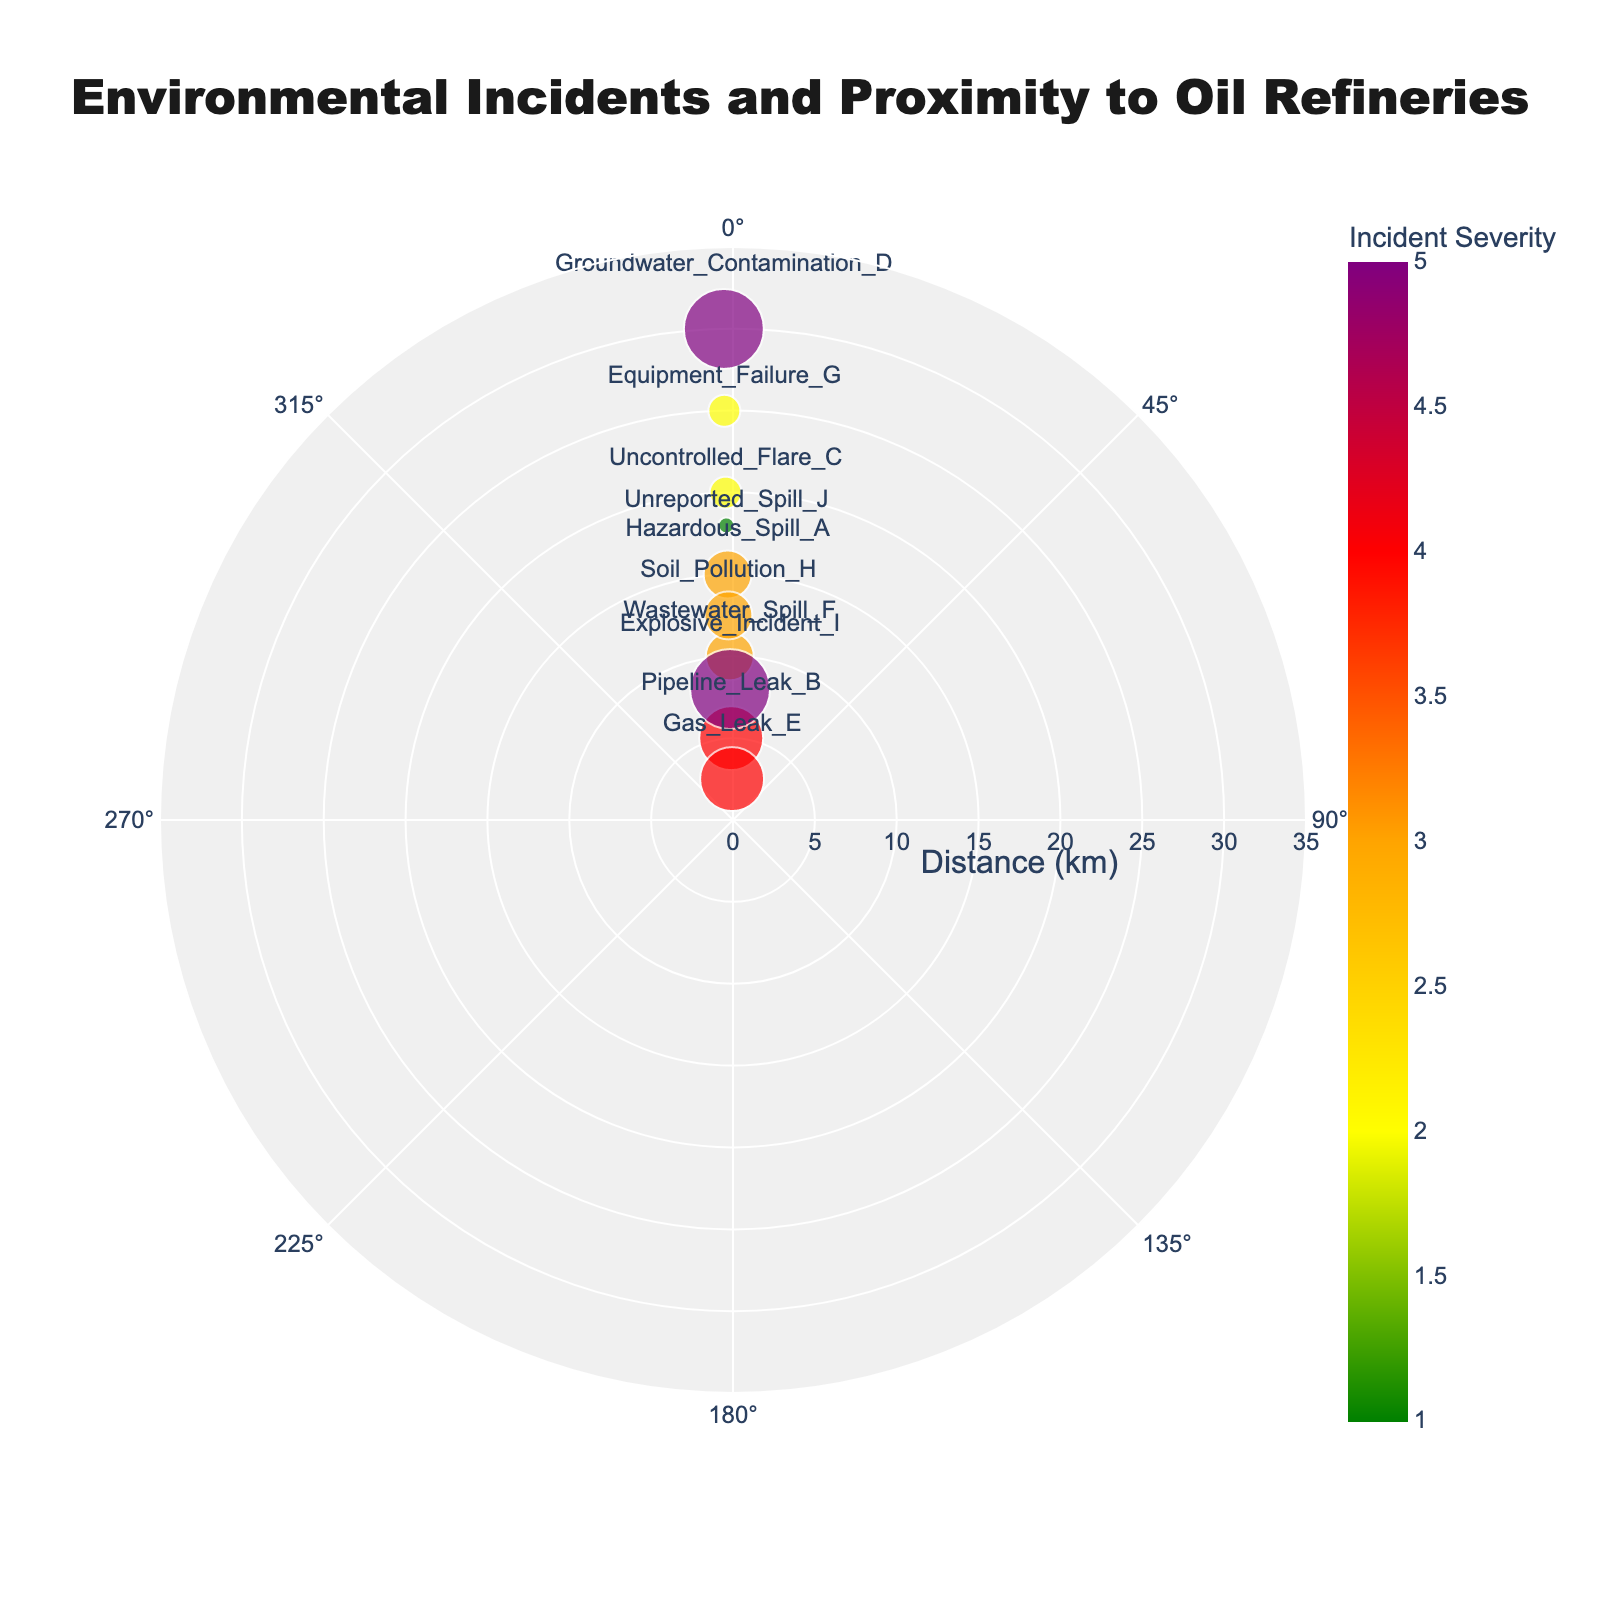What is the title of the figure? The title is usually the largest text at the top of the figure. It summarizes the main information presented.
Answer: Environmental Incidents and Proximity to Oil Refineries Which incident is the closest to the refinery? Identify the smallest 'Distance_to_Refinery_km' value in the plot. The smallest marker distance from the center corresponds to the closest incident.
Answer: Gas_Leak_E What color represents the highest incident severity on the color bar? Observe the color bar on the right side of the plot. The highest value should be at the top of the bar.
Answer: Purple How many incidents have a severity level of 5? Count the number of markers colored with the purple hue, corresponding to the highest severity level on the color bar.
Answer: 3 Which incident is located farthest from the refinery? Look for the marker farthest from the center of the plot, which represents the highest distance.
Answer: Groundwater_Contamination_D What is the average distance of incidents with a severity level of 4? Identify the distances for incidents with severity level 4, then calculate the average. The distances are 5.0 and 2.5 km. Average = (5.0 + 2.5) / 2 = 3.75 km.
Answer: 3.75 km Is there a relationship between distance from the refinery and incident severity? Explain. Observe if incidents with higher severity are closer or further from the center (0 km). Typically, high-severity incidents are closer to the refinery, visible as larger markers near the center.
Answer: Higher severity incidents are generally closer Which incident appears at an angular position of approximately 45 degrees? Identify the marker positioned at around 45 degrees from the horizontal axis. The angle θ in radians closely approximates 45 degrees.
Answer: Unreported_Spill_J Between Hazardous_Spill_A and Soil_Pollution_H, which has a higher severity? Compare the sizes and colors of the markers for Hazardous_Spill_A and Soil_Pollution_H. Larger size and darker color indicate higher severity.
Answer: Hazardous_Spill_A How many incidents are there within a 10 km radius of the refinery? Count the number of markers within the 10 km ring from the center. These indicate incidents closer than 10 km.
Answer: 3 